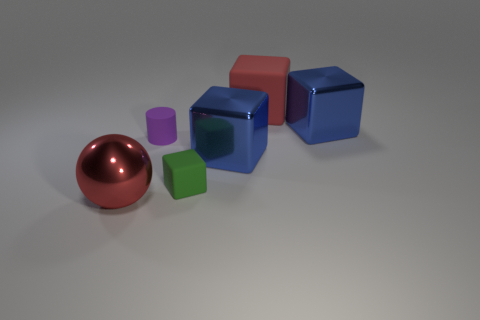Is there a big matte thing that has the same color as the metallic ball?
Offer a terse response. Yes. Are there any tiny yellow cubes that have the same material as the green cube?
Offer a very short reply. No. There is a thing that is in front of the tiny rubber cylinder and on the right side of the green block; what is its shape?
Ensure brevity in your answer.  Cube. What number of big things are purple metal balls or blue metallic objects?
Offer a terse response. 2. What material is the red block?
Your answer should be very brief. Rubber. What number of other things are the same shape as the purple object?
Provide a short and direct response. 0. What size is the red metallic ball?
Make the answer very short. Large. What size is the metallic object that is both to the left of the large matte block and behind the red metal ball?
Your answer should be compact. Large. The big blue thing that is on the right side of the red rubber object has what shape?
Provide a succinct answer. Cube. Are the big red sphere and the red object behind the tiny rubber cylinder made of the same material?
Your response must be concise. No. 